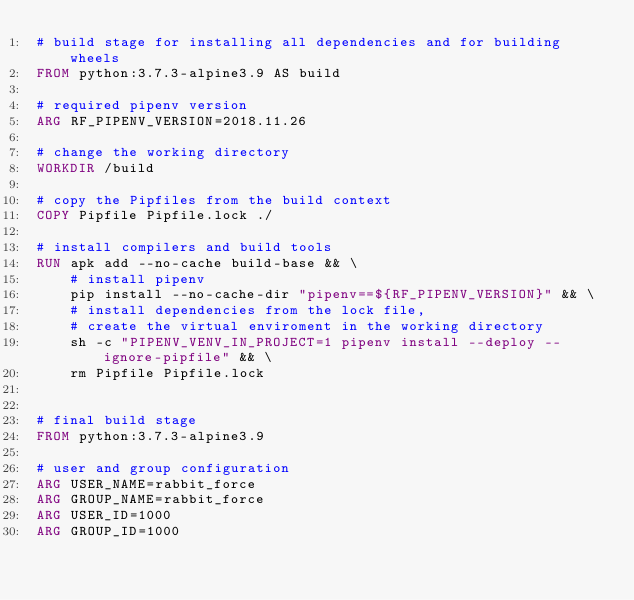Convert code to text. <code><loc_0><loc_0><loc_500><loc_500><_Dockerfile_># build stage for installing all dependencies and for building wheels
FROM python:3.7.3-alpine3.9 AS build

# required pipenv version
ARG RF_PIPENV_VERSION=2018.11.26

# change the working directory
WORKDIR /build

# copy the Pipfiles from the build context
COPY Pipfile Pipfile.lock ./

# install compilers and build tools
RUN apk add --no-cache build-base && \
    # install pipenv
    pip install --no-cache-dir "pipenv==${RF_PIPENV_VERSION}" && \
    # install dependencies from the lock file,
    # create the virtual enviroment in the working directory
    sh -c "PIPENV_VENV_IN_PROJECT=1 pipenv install --deploy --ignore-pipfile" && \
    rm Pipfile Pipfile.lock


# final build stage
FROM python:3.7.3-alpine3.9

# user and group configuration
ARG USER_NAME=rabbit_force
ARG GROUP_NAME=rabbit_force
ARG USER_ID=1000
ARG GROUP_ID=1000
</code> 